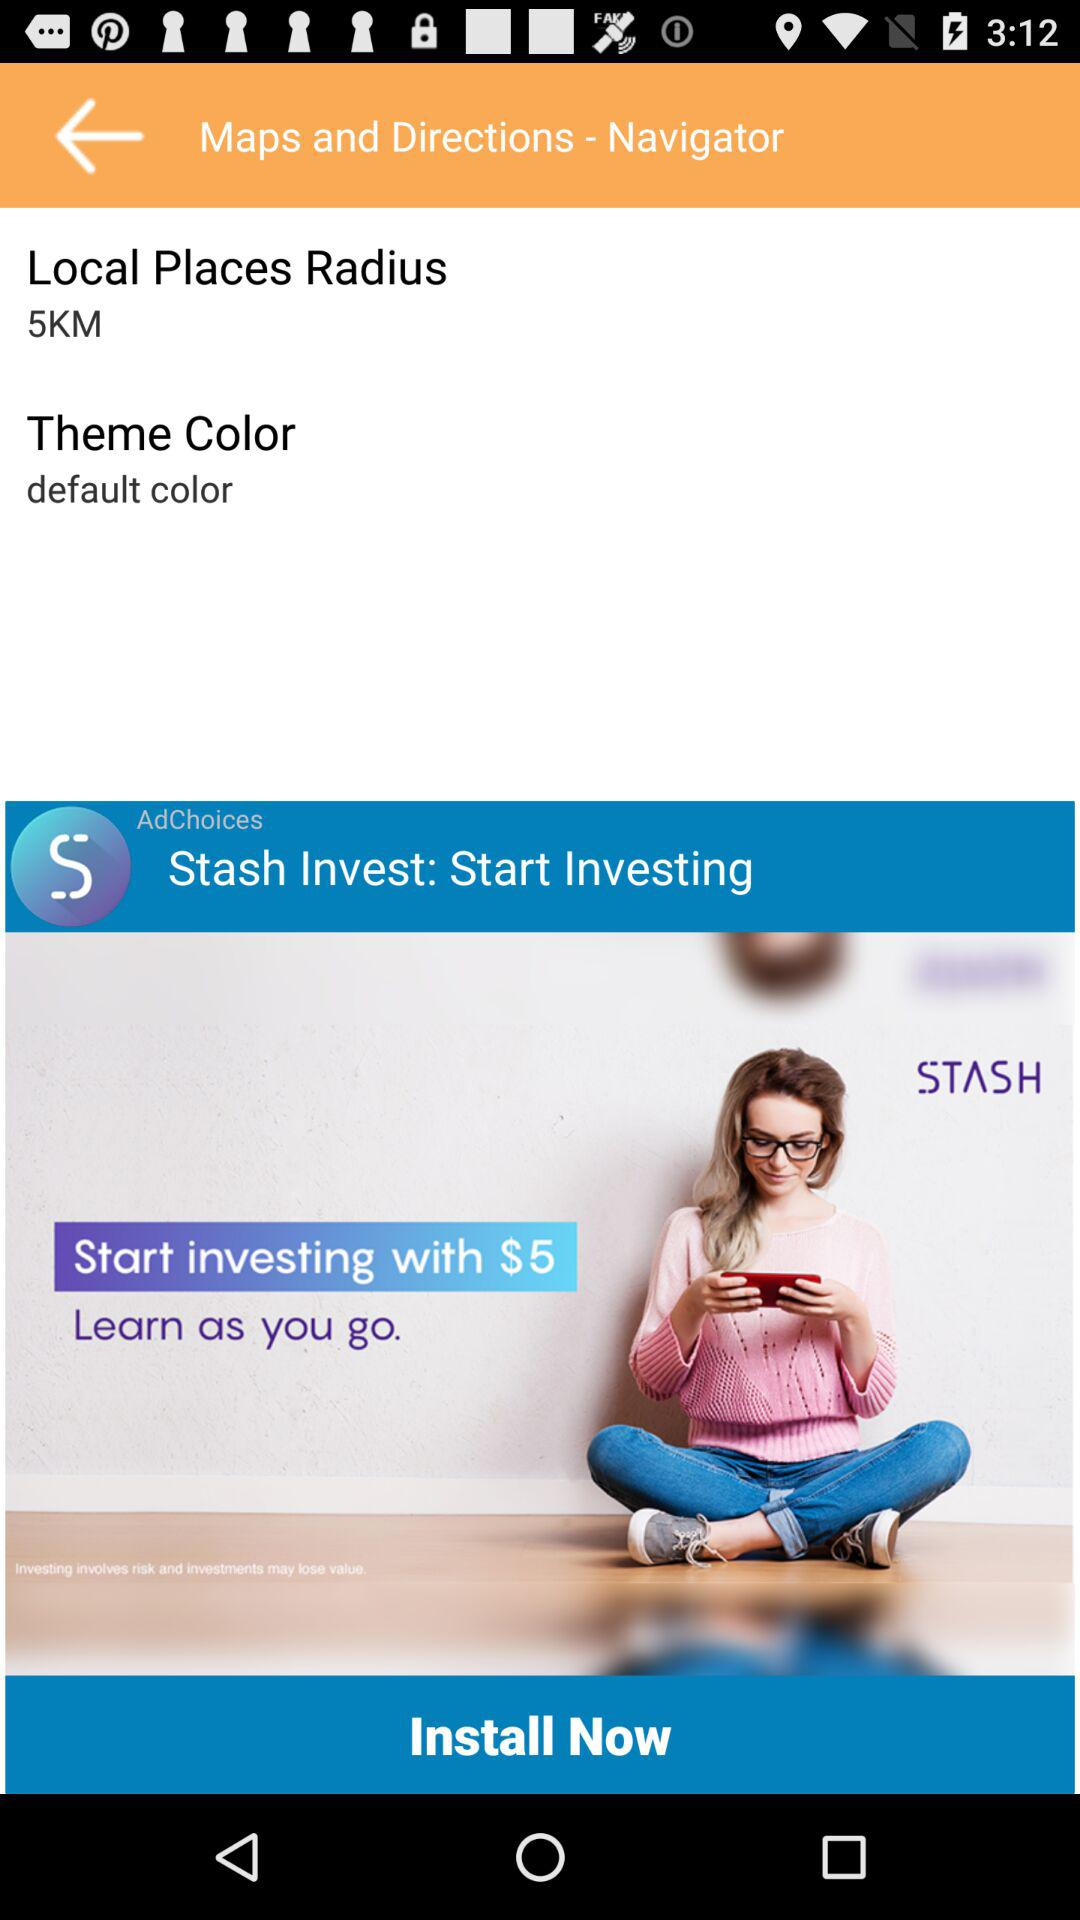What is "Local Places Radius"? "Local Places Radius" is 5 km. 